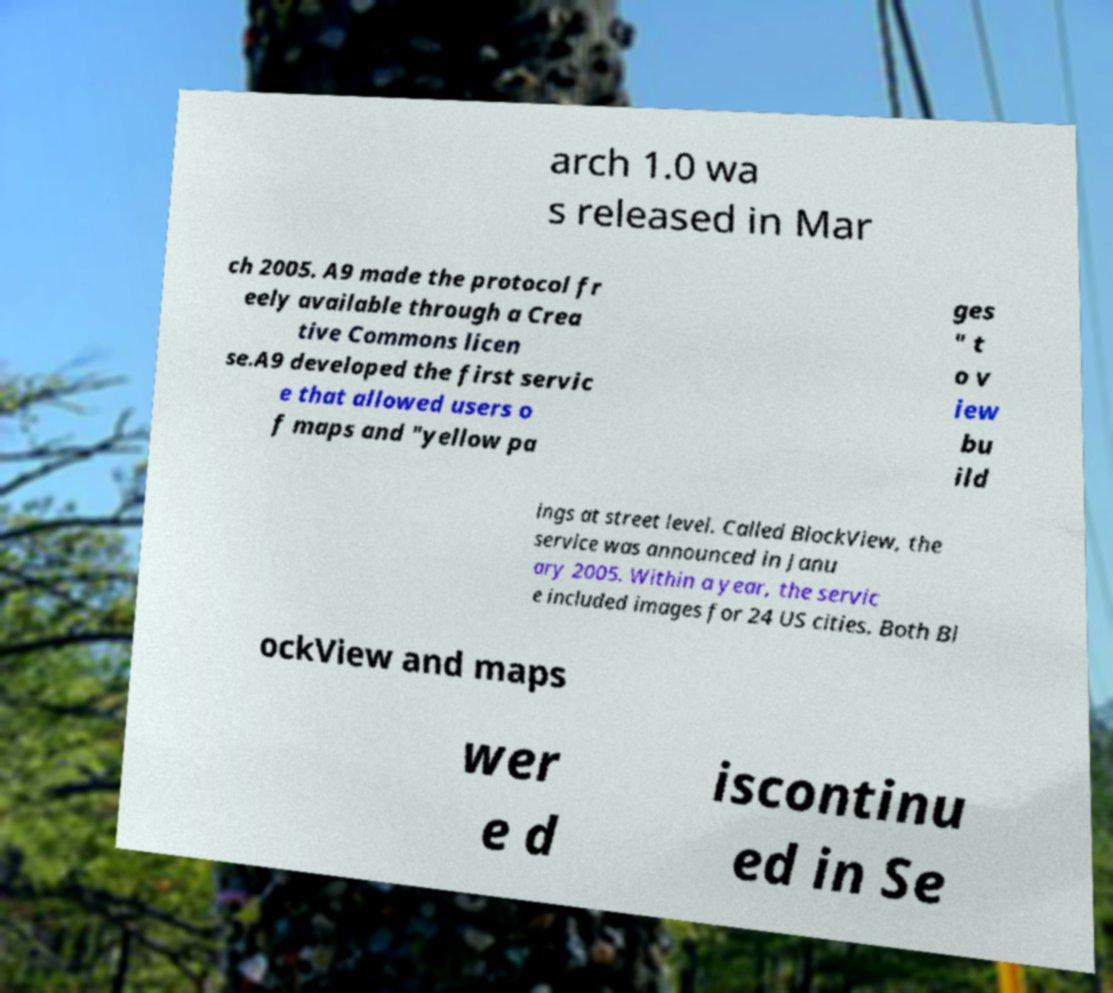I need the written content from this picture converted into text. Can you do that? arch 1.0 wa s released in Mar ch 2005. A9 made the protocol fr eely available through a Crea tive Commons licen se.A9 developed the first servic e that allowed users o f maps and "yellow pa ges " t o v iew bu ild ings at street level. Called BlockView, the service was announced in Janu ary 2005. Within a year, the servic e included images for 24 US cities. Both Bl ockView and maps wer e d iscontinu ed in Se 